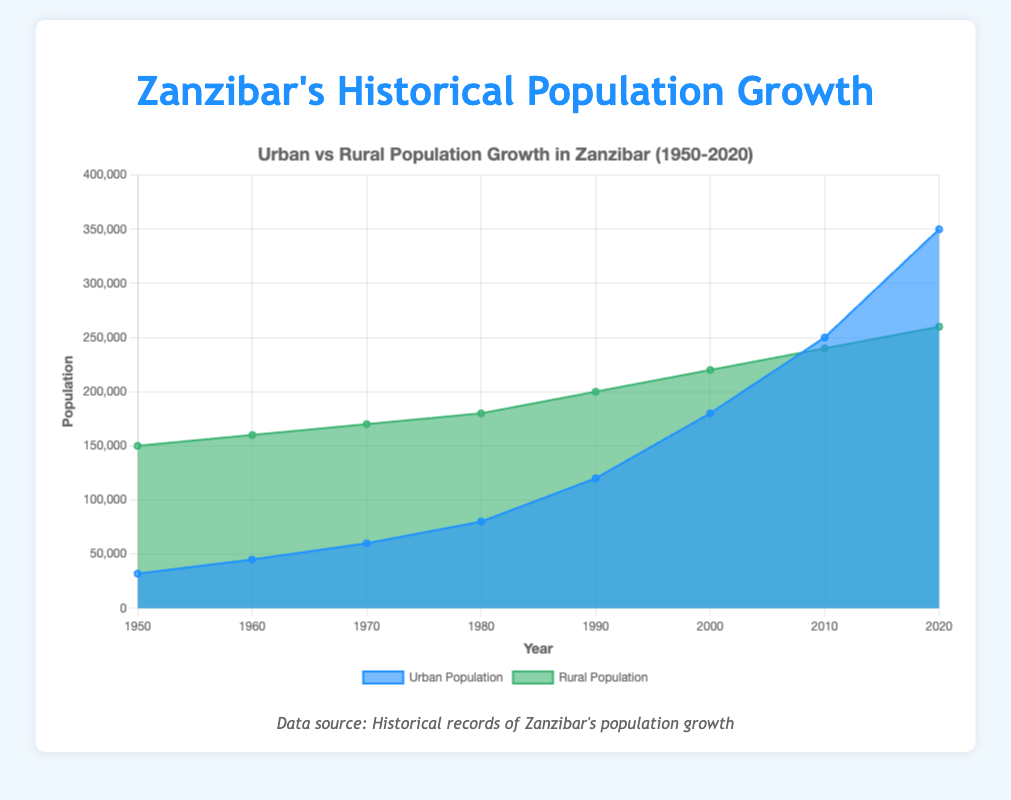What is the title of the chart? The title of the chart is located at the top and it reads, "Urban vs Rural Population Growth in Zanzibar (1950-2020)"
Answer: Urban vs Rural Population Growth in Zanzibar (1950-2020) How many years are covered in the chart? The x-axis shows the years from 1950 to 2020, stepping every decade, covering eight points in total.
Answer: 8 What is the maximum urban population recorded in the chart? The highest value in the urban population dataset is in 2020, where it reaches 350,000.
Answer: 350,000 In which decade did the urban population see the most significant increase? By examining the chart, the significant increase occurs between 2000 (180,000) and 2010 (250,000). So, the difference is 70,000, the highest decade-to-decade change.
Answer: 2000s What colors are used to represent urban and rural populations? The urban population is shown in shades of blue, while the rural population is displayed with shades of green.
Answer: Blue for urban, green for rural Which population was higher in 1980, urban or rural? How much higher was it? In 1980, the urban population was 80,000 while the rural population was 180,000. The rural population was higher by 100,000.
Answer: Rural, by 100,000 Can you observe any year where the rural population declined? No, based on the chart, there is no year where the rural population shows a decline; it consistently increases.
Answer: No What is the trend observed in the urban population from 1950 to 2020? The urban population shows a gradual increase from 1950 to 1990, then experiences a significant rise post-1990, with a steep increase observed into 2020.
Answer: Gradual increase, then steep rise Calculate the total population (urban + rural) for 2020? The population for 2020 is the sum of the urban population (350,000) and the rural population (260,000), giving a total of 610,000.
Answer: 610,000 Which had a faster growth rate from 1950 to 2020, urban or rural population? By comparing the initial and final values: Urban from 32,000 to 350,000 (growth of 318,000) and Rural from 150,000 to 260,000 (growth of 110,000); urban growth is faster.
Answer: Urban population 